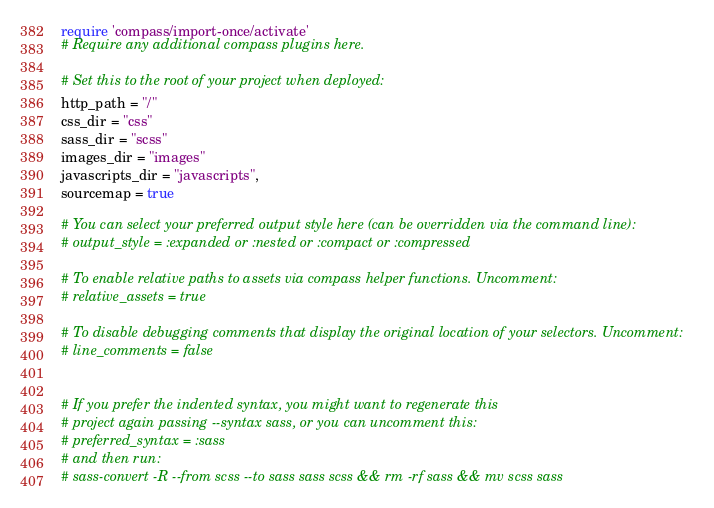Convert code to text. <code><loc_0><loc_0><loc_500><loc_500><_Ruby_>require 'compass/import-once/activate'
# Require any additional compass plugins here.

# Set this to the root of your project when deployed:
http_path = "/"
css_dir = "css"
sass_dir = "scss"
images_dir = "images"
javascripts_dir = "javascripts",
sourcemap = true

# You can select your preferred output style here (can be overridden via the command line):
# output_style = :expanded or :nested or :compact or :compressed

# To enable relative paths to assets via compass helper functions. Uncomment:
# relative_assets = true

# To disable debugging comments that display the original location of your selectors. Uncomment:
# line_comments = false


# If you prefer the indented syntax, you might want to regenerate this
# project again passing --syntax sass, or you can uncomment this:
# preferred_syntax = :sass
# and then run:
# sass-convert -R --from scss --to sass sass scss && rm -rf sass && mv scss sass
</code> 